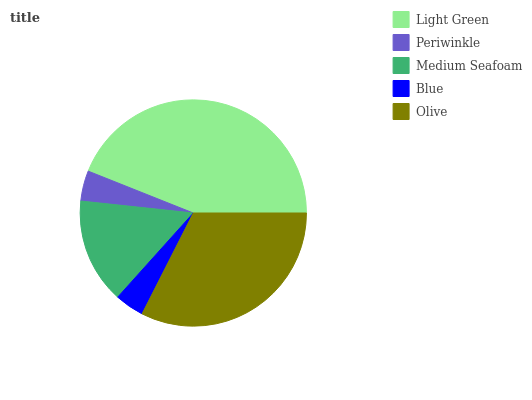Is Blue the minimum?
Answer yes or no. Yes. Is Light Green the maximum?
Answer yes or no. Yes. Is Periwinkle the minimum?
Answer yes or no. No. Is Periwinkle the maximum?
Answer yes or no. No. Is Light Green greater than Periwinkle?
Answer yes or no. Yes. Is Periwinkle less than Light Green?
Answer yes or no. Yes. Is Periwinkle greater than Light Green?
Answer yes or no. No. Is Light Green less than Periwinkle?
Answer yes or no. No. Is Medium Seafoam the high median?
Answer yes or no. Yes. Is Medium Seafoam the low median?
Answer yes or no. Yes. Is Olive the high median?
Answer yes or no. No. Is Periwinkle the low median?
Answer yes or no. No. 